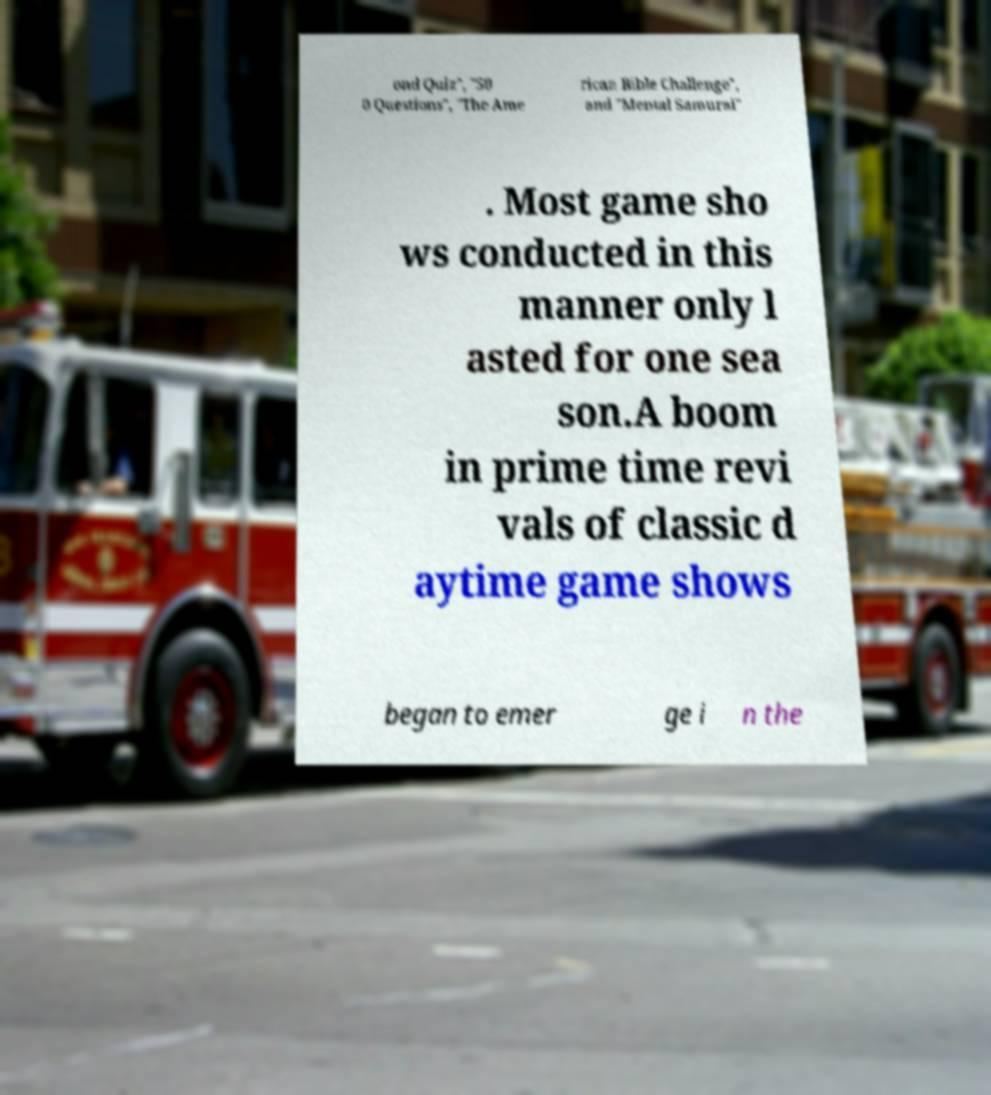What messages or text are displayed in this image? I need them in a readable, typed format. ond Quiz", "50 0 Questions", "The Ame rican Bible Challenge", and "Mental Samurai" . Most game sho ws conducted in this manner only l asted for one sea son.A boom in prime time revi vals of classic d aytime game shows began to emer ge i n the 